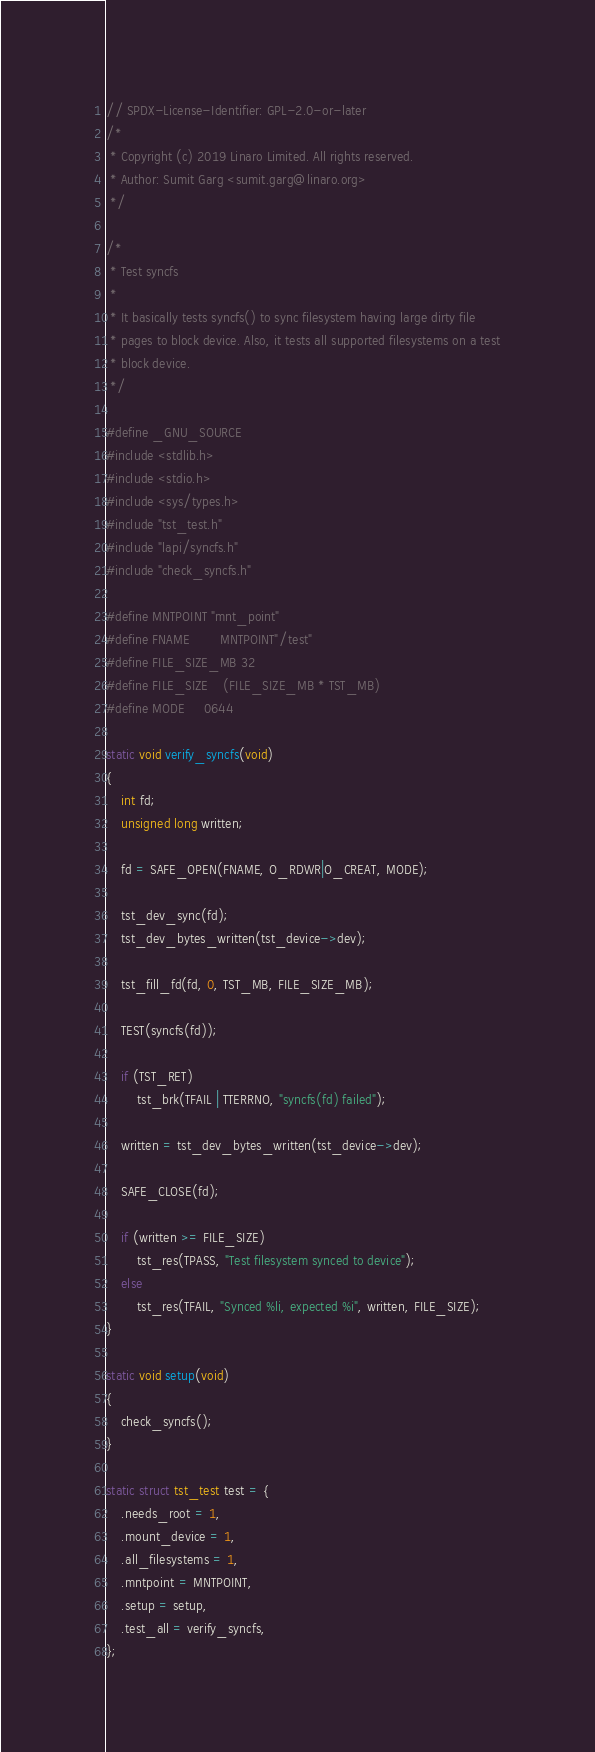<code> <loc_0><loc_0><loc_500><loc_500><_C_>// SPDX-License-Identifier: GPL-2.0-or-later
/*
 * Copyright (c) 2019 Linaro Limited. All rights reserved.
 * Author: Sumit Garg <sumit.garg@linaro.org>
 */

/*
 * Test syncfs
 *
 * It basically tests syncfs() to sync filesystem having large dirty file
 * pages to block device. Also, it tests all supported filesystems on a test
 * block device.
 */

#define _GNU_SOURCE
#include <stdlib.h>
#include <stdio.h>
#include <sys/types.h>
#include "tst_test.h"
#include "lapi/syncfs.h"
#include "check_syncfs.h"

#define MNTPOINT	"mnt_point"
#define FNAME		MNTPOINT"/test"
#define FILE_SIZE_MB	32
#define FILE_SIZE	(FILE_SIZE_MB * TST_MB)
#define MODE		0644

static void verify_syncfs(void)
{
	int fd;
	unsigned long written;

	fd = SAFE_OPEN(FNAME, O_RDWR|O_CREAT, MODE);

	tst_dev_sync(fd);
	tst_dev_bytes_written(tst_device->dev);

	tst_fill_fd(fd, 0, TST_MB, FILE_SIZE_MB);

	TEST(syncfs(fd));

	if (TST_RET)
		tst_brk(TFAIL | TTERRNO, "syncfs(fd) failed");

	written = tst_dev_bytes_written(tst_device->dev);

	SAFE_CLOSE(fd);

	if (written >= FILE_SIZE)
		tst_res(TPASS, "Test filesystem synced to device");
	else
		tst_res(TFAIL, "Synced %li, expected %i", written, FILE_SIZE);
}

static void setup(void)
{
	check_syncfs();
}

static struct tst_test test = {
	.needs_root = 1,
	.mount_device = 1,
	.all_filesystems = 1,
	.mntpoint = MNTPOINT,
	.setup = setup,
	.test_all = verify_syncfs,
};
</code> 